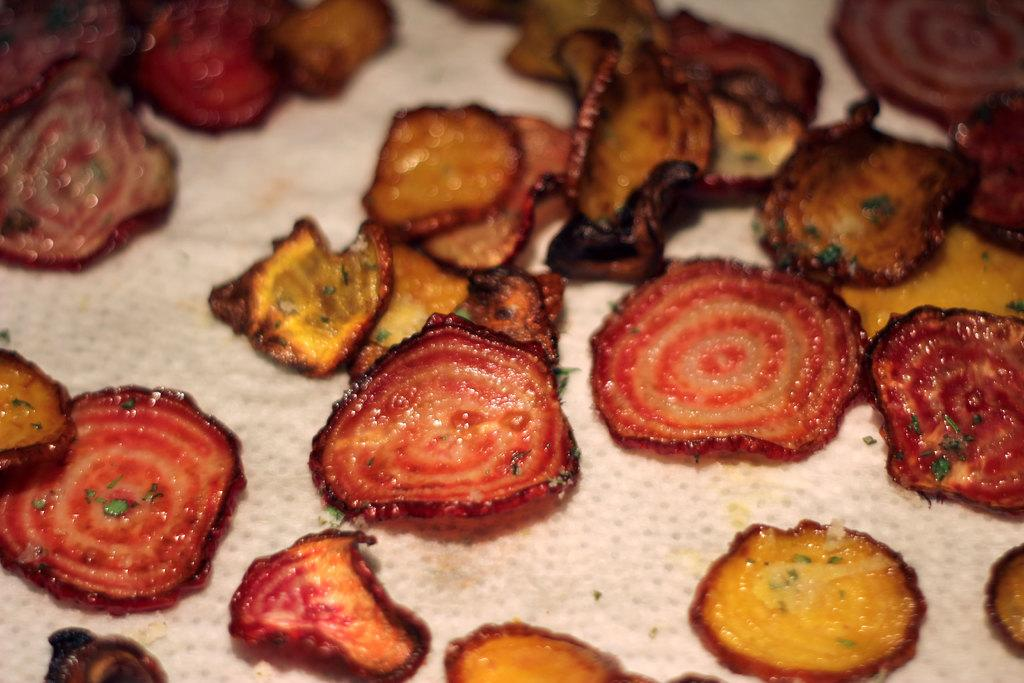What is present on the ground in the image? There are food items on the ground in the image. Can you describe the food items in the image? Unfortunately, the provided facts do not specify the type of food items present in the image. What might be the reason for the food items being on the ground? Without additional context, it is difficult to determine the reason for the food items being on the ground. Can you describe the thumb in the image? There is no thumb present in the image. What type of action is taking place in the image? The provided facts do not mention any specific actions taking place in the image. Is the ocean visible in the image? The provided facts do not mention the ocean or any water bodies in the image. 